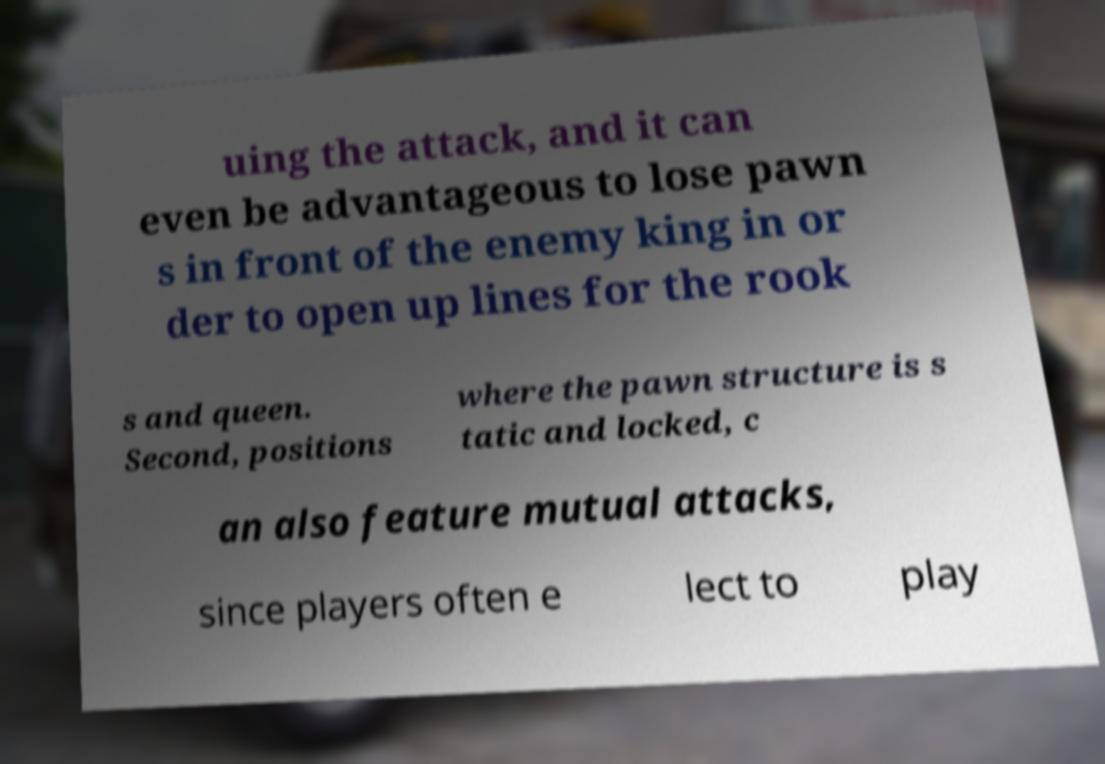Could you extract and type out the text from this image? uing the attack, and it can even be advantageous to lose pawn s in front of the enemy king in or der to open up lines for the rook s and queen. Second, positions where the pawn structure is s tatic and locked, c an also feature mutual attacks, since players often e lect to play 